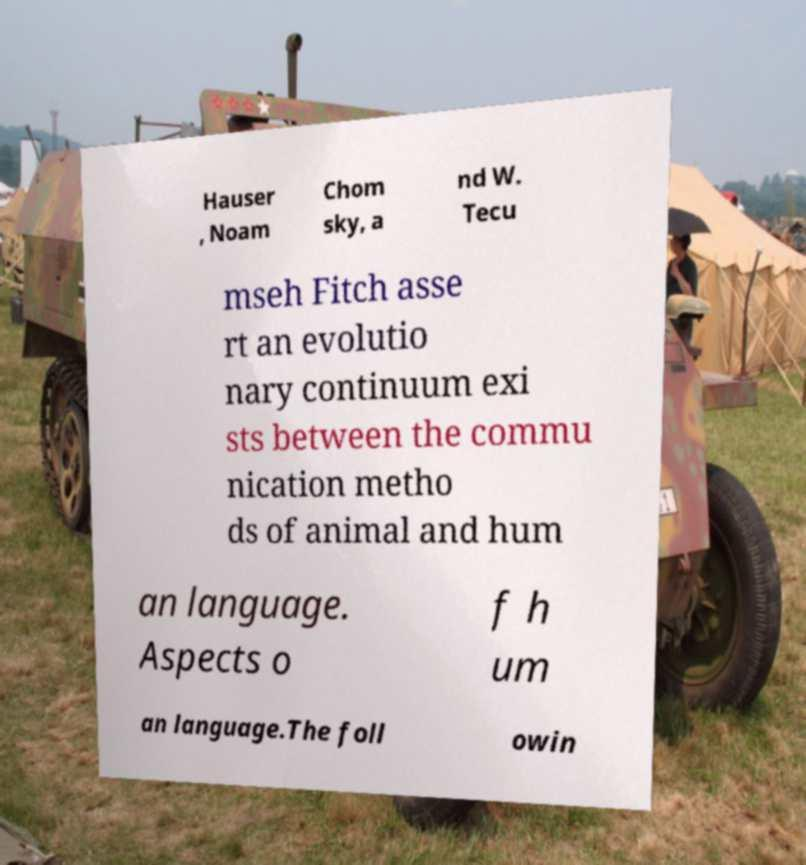For documentation purposes, I need the text within this image transcribed. Could you provide that? Hauser , Noam Chom sky, a nd W. Tecu mseh Fitch asse rt an evolutio nary continuum exi sts between the commu nication metho ds of animal and hum an language. Aspects o f h um an language.The foll owin 